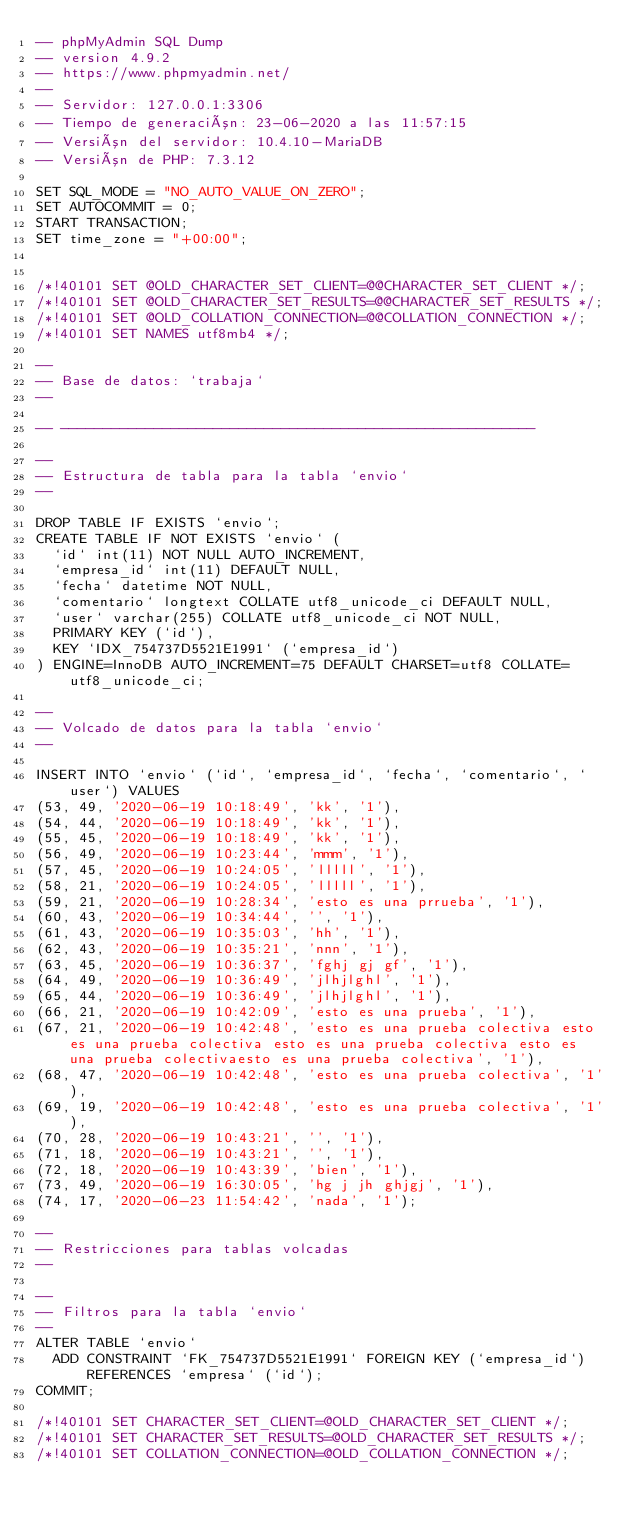<code> <loc_0><loc_0><loc_500><loc_500><_SQL_>-- phpMyAdmin SQL Dump
-- version 4.9.2
-- https://www.phpmyadmin.net/
--
-- Servidor: 127.0.0.1:3306
-- Tiempo de generación: 23-06-2020 a las 11:57:15
-- Versión del servidor: 10.4.10-MariaDB
-- Versión de PHP: 7.3.12

SET SQL_MODE = "NO_AUTO_VALUE_ON_ZERO";
SET AUTOCOMMIT = 0;
START TRANSACTION;
SET time_zone = "+00:00";


/*!40101 SET @OLD_CHARACTER_SET_CLIENT=@@CHARACTER_SET_CLIENT */;
/*!40101 SET @OLD_CHARACTER_SET_RESULTS=@@CHARACTER_SET_RESULTS */;
/*!40101 SET @OLD_COLLATION_CONNECTION=@@COLLATION_CONNECTION */;
/*!40101 SET NAMES utf8mb4 */;

--
-- Base de datos: `trabaja`
--

-- --------------------------------------------------------

--
-- Estructura de tabla para la tabla `envio`
--

DROP TABLE IF EXISTS `envio`;
CREATE TABLE IF NOT EXISTS `envio` (
  `id` int(11) NOT NULL AUTO_INCREMENT,
  `empresa_id` int(11) DEFAULT NULL,
  `fecha` datetime NOT NULL,
  `comentario` longtext COLLATE utf8_unicode_ci DEFAULT NULL,
  `user` varchar(255) COLLATE utf8_unicode_ci NOT NULL,
  PRIMARY KEY (`id`),
  KEY `IDX_754737D5521E1991` (`empresa_id`)
) ENGINE=InnoDB AUTO_INCREMENT=75 DEFAULT CHARSET=utf8 COLLATE=utf8_unicode_ci;

--
-- Volcado de datos para la tabla `envio`
--

INSERT INTO `envio` (`id`, `empresa_id`, `fecha`, `comentario`, `user`) VALUES
(53, 49, '2020-06-19 10:18:49', 'kk', '1'),
(54, 44, '2020-06-19 10:18:49', 'kk', '1'),
(55, 45, '2020-06-19 10:18:49', 'kk', '1'),
(56, 49, '2020-06-19 10:23:44', 'mmm', '1'),
(57, 45, '2020-06-19 10:24:05', 'lllll', '1'),
(58, 21, '2020-06-19 10:24:05', 'lllll', '1'),
(59, 21, '2020-06-19 10:28:34', 'esto es una prrueba', '1'),
(60, 43, '2020-06-19 10:34:44', '', '1'),
(61, 43, '2020-06-19 10:35:03', 'hh', '1'),
(62, 43, '2020-06-19 10:35:21', 'nnn', '1'),
(63, 45, '2020-06-19 10:36:37', 'fghj gj gf', '1'),
(64, 49, '2020-06-19 10:36:49', 'jlhjlghl', '1'),
(65, 44, '2020-06-19 10:36:49', 'jlhjlghl', '1'),
(66, 21, '2020-06-19 10:42:09', 'esto es una prueba', '1'),
(67, 21, '2020-06-19 10:42:48', 'esto es una prueba colectiva esto es una prueba colectiva esto es una prueba colectiva esto es una prueba colectivaesto es una prueba colectiva', '1'),
(68, 47, '2020-06-19 10:42:48', 'esto es una prueba colectiva', '1'),
(69, 19, '2020-06-19 10:42:48', 'esto es una prueba colectiva', '1'),
(70, 28, '2020-06-19 10:43:21', '', '1'),
(71, 18, '2020-06-19 10:43:21', '', '1'),
(72, 18, '2020-06-19 10:43:39', 'bien', '1'),
(73, 49, '2020-06-19 16:30:05', 'hg j jh ghjgj', '1'),
(74, 17, '2020-06-23 11:54:42', 'nada', '1');

--
-- Restricciones para tablas volcadas
--

--
-- Filtros para la tabla `envio`
--
ALTER TABLE `envio`
  ADD CONSTRAINT `FK_754737D5521E1991` FOREIGN KEY (`empresa_id`) REFERENCES `empresa` (`id`);
COMMIT;

/*!40101 SET CHARACTER_SET_CLIENT=@OLD_CHARACTER_SET_CLIENT */;
/*!40101 SET CHARACTER_SET_RESULTS=@OLD_CHARACTER_SET_RESULTS */;
/*!40101 SET COLLATION_CONNECTION=@OLD_COLLATION_CONNECTION */;
</code> 